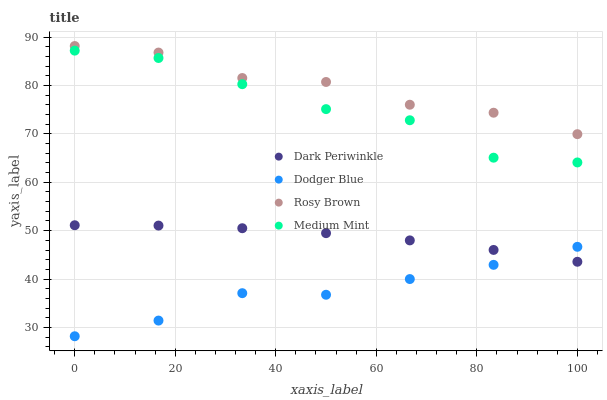Does Dodger Blue have the minimum area under the curve?
Answer yes or no. Yes. Does Rosy Brown have the maximum area under the curve?
Answer yes or no. Yes. Does Rosy Brown have the minimum area under the curve?
Answer yes or no. No. Does Dodger Blue have the maximum area under the curve?
Answer yes or no. No. Is Dark Periwinkle the smoothest?
Answer yes or no. Yes. Is Medium Mint the roughest?
Answer yes or no. Yes. Is Rosy Brown the smoothest?
Answer yes or no. No. Is Rosy Brown the roughest?
Answer yes or no. No. Does Dodger Blue have the lowest value?
Answer yes or no. Yes. Does Rosy Brown have the lowest value?
Answer yes or no. No. Does Rosy Brown have the highest value?
Answer yes or no. Yes. Does Dodger Blue have the highest value?
Answer yes or no. No. Is Dark Periwinkle less than Medium Mint?
Answer yes or no. Yes. Is Rosy Brown greater than Medium Mint?
Answer yes or no. Yes. Does Dodger Blue intersect Dark Periwinkle?
Answer yes or no. Yes. Is Dodger Blue less than Dark Periwinkle?
Answer yes or no. No. Is Dodger Blue greater than Dark Periwinkle?
Answer yes or no. No. Does Dark Periwinkle intersect Medium Mint?
Answer yes or no. No. 